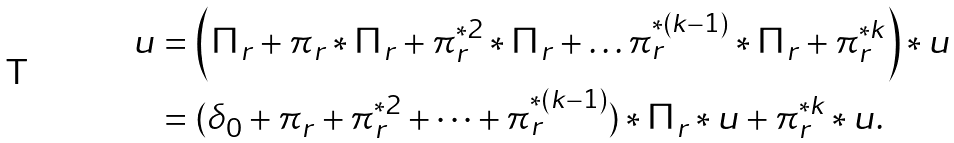<formula> <loc_0><loc_0><loc_500><loc_500>u & = \left ( \Pi _ { r } + \pi _ { r } \ast \Pi _ { r } + \pi _ { r } ^ { \ast 2 } \ast \Pi _ { r } + \dots \pi _ { r } ^ { \ast ( k - 1 ) } \ast \Pi _ { r } + \pi _ { r } ^ { \ast k } \right ) \ast u \\ & = ( \delta _ { 0 } + \pi _ { r } + \pi _ { r } ^ { \ast 2 } + \dots + \pi _ { r } ^ { \ast ( k - 1 ) } ) \ast \Pi _ { r } \ast u + \pi _ { r } ^ { \ast k } \ast u .</formula> 